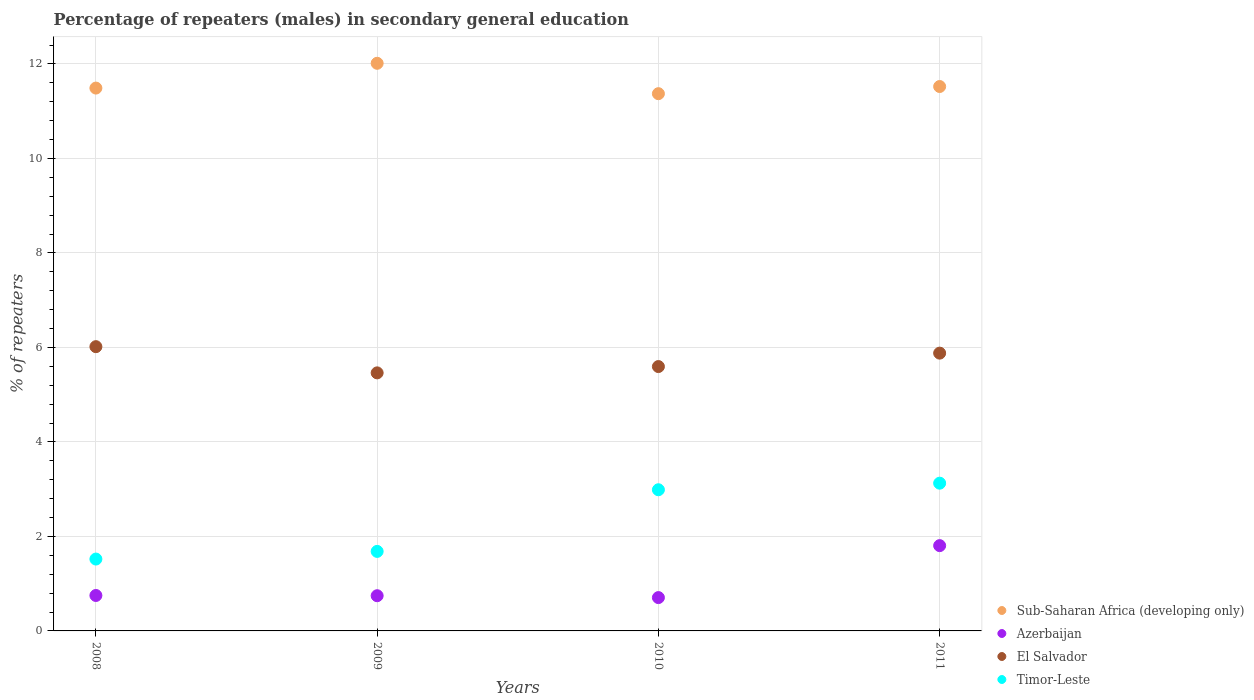Is the number of dotlines equal to the number of legend labels?
Make the answer very short. Yes. What is the percentage of male repeaters in Sub-Saharan Africa (developing only) in 2009?
Give a very brief answer. 12.01. Across all years, what is the maximum percentage of male repeaters in El Salvador?
Ensure brevity in your answer.  6.02. Across all years, what is the minimum percentage of male repeaters in Timor-Leste?
Give a very brief answer. 1.52. In which year was the percentage of male repeaters in El Salvador minimum?
Ensure brevity in your answer.  2009. What is the total percentage of male repeaters in El Salvador in the graph?
Ensure brevity in your answer.  22.95. What is the difference between the percentage of male repeaters in Azerbaijan in 2008 and that in 2010?
Your answer should be very brief. 0.04. What is the difference between the percentage of male repeaters in Sub-Saharan Africa (developing only) in 2011 and the percentage of male repeaters in Timor-Leste in 2009?
Make the answer very short. 9.84. What is the average percentage of male repeaters in Timor-Leste per year?
Offer a very short reply. 2.33. In the year 2008, what is the difference between the percentage of male repeaters in El Salvador and percentage of male repeaters in Timor-Leste?
Provide a succinct answer. 4.5. What is the ratio of the percentage of male repeaters in Timor-Leste in 2008 to that in 2011?
Your answer should be very brief. 0.49. Is the difference between the percentage of male repeaters in El Salvador in 2008 and 2009 greater than the difference between the percentage of male repeaters in Timor-Leste in 2008 and 2009?
Offer a very short reply. Yes. What is the difference between the highest and the second highest percentage of male repeaters in Sub-Saharan Africa (developing only)?
Ensure brevity in your answer.  0.49. What is the difference between the highest and the lowest percentage of male repeaters in Sub-Saharan Africa (developing only)?
Make the answer very short. 0.64. Is it the case that in every year, the sum of the percentage of male repeaters in Azerbaijan and percentage of male repeaters in Timor-Leste  is greater than the sum of percentage of male repeaters in El Salvador and percentage of male repeaters in Sub-Saharan Africa (developing only)?
Your answer should be very brief. No. Is it the case that in every year, the sum of the percentage of male repeaters in Timor-Leste and percentage of male repeaters in Azerbaijan  is greater than the percentage of male repeaters in El Salvador?
Offer a terse response. No. Is the percentage of male repeaters in Azerbaijan strictly greater than the percentage of male repeaters in Sub-Saharan Africa (developing only) over the years?
Offer a very short reply. No. Is the percentage of male repeaters in Azerbaijan strictly less than the percentage of male repeaters in El Salvador over the years?
Keep it short and to the point. Yes. Does the graph contain grids?
Ensure brevity in your answer.  Yes. How are the legend labels stacked?
Offer a terse response. Vertical. What is the title of the graph?
Provide a short and direct response. Percentage of repeaters (males) in secondary general education. Does "Iraq" appear as one of the legend labels in the graph?
Offer a terse response. No. What is the label or title of the X-axis?
Give a very brief answer. Years. What is the label or title of the Y-axis?
Your answer should be very brief. % of repeaters. What is the % of repeaters of Sub-Saharan Africa (developing only) in 2008?
Offer a very short reply. 11.49. What is the % of repeaters in Azerbaijan in 2008?
Offer a very short reply. 0.75. What is the % of repeaters in El Salvador in 2008?
Provide a short and direct response. 6.02. What is the % of repeaters in Timor-Leste in 2008?
Provide a short and direct response. 1.52. What is the % of repeaters in Sub-Saharan Africa (developing only) in 2009?
Ensure brevity in your answer.  12.01. What is the % of repeaters in Azerbaijan in 2009?
Provide a succinct answer. 0.75. What is the % of repeaters in El Salvador in 2009?
Your answer should be compact. 5.46. What is the % of repeaters in Timor-Leste in 2009?
Provide a short and direct response. 1.68. What is the % of repeaters in Sub-Saharan Africa (developing only) in 2010?
Your answer should be very brief. 11.37. What is the % of repeaters in Azerbaijan in 2010?
Keep it short and to the point. 0.71. What is the % of repeaters of El Salvador in 2010?
Make the answer very short. 5.6. What is the % of repeaters in Timor-Leste in 2010?
Offer a very short reply. 2.99. What is the % of repeaters in Sub-Saharan Africa (developing only) in 2011?
Keep it short and to the point. 11.52. What is the % of repeaters in Azerbaijan in 2011?
Provide a succinct answer. 1.81. What is the % of repeaters of El Salvador in 2011?
Give a very brief answer. 5.88. What is the % of repeaters of Timor-Leste in 2011?
Offer a very short reply. 3.13. Across all years, what is the maximum % of repeaters of Sub-Saharan Africa (developing only)?
Provide a succinct answer. 12.01. Across all years, what is the maximum % of repeaters in Azerbaijan?
Your answer should be compact. 1.81. Across all years, what is the maximum % of repeaters in El Salvador?
Your answer should be very brief. 6.02. Across all years, what is the maximum % of repeaters of Timor-Leste?
Provide a succinct answer. 3.13. Across all years, what is the minimum % of repeaters in Sub-Saharan Africa (developing only)?
Make the answer very short. 11.37. Across all years, what is the minimum % of repeaters in Azerbaijan?
Your answer should be very brief. 0.71. Across all years, what is the minimum % of repeaters of El Salvador?
Provide a short and direct response. 5.46. Across all years, what is the minimum % of repeaters in Timor-Leste?
Your response must be concise. 1.52. What is the total % of repeaters in Sub-Saharan Africa (developing only) in the graph?
Offer a very short reply. 46.4. What is the total % of repeaters in Azerbaijan in the graph?
Your response must be concise. 4.01. What is the total % of repeaters of El Salvador in the graph?
Your response must be concise. 22.95. What is the total % of repeaters in Timor-Leste in the graph?
Make the answer very short. 9.32. What is the difference between the % of repeaters in Sub-Saharan Africa (developing only) in 2008 and that in 2009?
Keep it short and to the point. -0.52. What is the difference between the % of repeaters in Azerbaijan in 2008 and that in 2009?
Offer a terse response. 0.01. What is the difference between the % of repeaters of El Salvador in 2008 and that in 2009?
Offer a very short reply. 0.55. What is the difference between the % of repeaters in Timor-Leste in 2008 and that in 2009?
Keep it short and to the point. -0.16. What is the difference between the % of repeaters in Sub-Saharan Africa (developing only) in 2008 and that in 2010?
Offer a terse response. 0.12. What is the difference between the % of repeaters of Azerbaijan in 2008 and that in 2010?
Your answer should be very brief. 0.04. What is the difference between the % of repeaters in El Salvador in 2008 and that in 2010?
Ensure brevity in your answer.  0.42. What is the difference between the % of repeaters of Timor-Leste in 2008 and that in 2010?
Offer a terse response. -1.47. What is the difference between the % of repeaters in Sub-Saharan Africa (developing only) in 2008 and that in 2011?
Offer a terse response. -0.03. What is the difference between the % of repeaters in Azerbaijan in 2008 and that in 2011?
Make the answer very short. -1.06. What is the difference between the % of repeaters of El Salvador in 2008 and that in 2011?
Provide a succinct answer. 0.14. What is the difference between the % of repeaters of Timor-Leste in 2008 and that in 2011?
Keep it short and to the point. -1.61. What is the difference between the % of repeaters in Sub-Saharan Africa (developing only) in 2009 and that in 2010?
Make the answer very short. 0.64. What is the difference between the % of repeaters in Azerbaijan in 2009 and that in 2010?
Provide a short and direct response. 0.04. What is the difference between the % of repeaters in El Salvador in 2009 and that in 2010?
Make the answer very short. -0.13. What is the difference between the % of repeaters of Timor-Leste in 2009 and that in 2010?
Provide a short and direct response. -1.3. What is the difference between the % of repeaters in Sub-Saharan Africa (developing only) in 2009 and that in 2011?
Your answer should be compact. 0.49. What is the difference between the % of repeaters of Azerbaijan in 2009 and that in 2011?
Offer a very short reply. -1.06. What is the difference between the % of repeaters in El Salvador in 2009 and that in 2011?
Your response must be concise. -0.42. What is the difference between the % of repeaters of Timor-Leste in 2009 and that in 2011?
Offer a terse response. -1.44. What is the difference between the % of repeaters of Sub-Saharan Africa (developing only) in 2010 and that in 2011?
Offer a terse response. -0.15. What is the difference between the % of repeaters of Azerbaijan in 2010 and that in 2011?
Make the answer very short. -1.1. What is the difference between the % of repeaters of El Salvador in 2010 and that in 2011?
Keep it short and to the point. -0.28. What is the difference between the % of repeaters in Timor-Leste in 2010 and that in 2011?
Ensure brevity in your answer.  -0.14. What is the difference between the % of repeaters in Sub-Saharan Africa (developing only) in 2008 and the % of repeaters in Azerbaijan in 2009?
Your answer should be very brief. 10.74. What is the difference between the % of repeaters of Sub-Saharan Africa (developing only) in 2008 and the % of repeaters of El Salvador in 2009?
Ensure brevity in your answer.  6.03. What is the difference between the % of repeaters in Sub-Saharan Africa (developing only) in 2008 and the % of repeaters in Timor-Leste in 2009?
Provide a succinct answer. 9.81. What is the difference between the % of repeaters in Azerbaijan in 2008 and the % of repeaters in El Salvador in 2009?
Make the answer very short. -4.71. What is the difference between the % of repeaters of Azerbaijan in 2008 and the % of repeaters of Timor-Leste in 2009?
Give a very brief answer. -0.93. What is the difference between the % of repeaters of El Salvador in 2008 and the % of repeaters of Timor-Leste in 2009?
Offer a terse response. 4.33. What is the difference between the % of repeaters in Sub-Saharan Africa (developing only) in 2008 and the % of repeaters in Azerbaijan in 2010?
Your answer should be compact. 10.78. What is the difference between the % of repeaters in Sub-Saharan Africa (developing only) in 2008 and the % of repeaters in El Salvador in 2010?
Provide a short and direct response. 5.89. What is the difference between the % of repeaters of Sub-Saharan Africa (developing only) in 2008 and the % of repeaters of Timor-Leste in 2010?
Keep it short and to the point. 8.5. What is the difference between the % of repeaters of Azerbaijan in 2008 and the % of repeaters of El Salvador in 2010?
Your answer should be compact. -4.85. What is the difference between the % of repeaters in Azerbaijan in 2008 and the % of repeaters in Timor-Leste in 2010?
Your response must be concise. -2.24. What is the difference between the % of repeaters of El Salvador in 2008 and the % of repeaters of Timor-Leste in 2010?
Your answer should be very brief. 3.03. What is the difference between the % of repeaters of Sub-Saharan Africa (developing only) in 2008 and the % of repeaters of Azerbaijan in 2011?
Ensure brevity in your answer.  9.68. What is the difference between the % of repeaters of Sub-Saharan Africa (developing only) in 2008 and the % of repeaters of El Salvador in 2011?
Provide a short and direct response. 5.61. What is the difference between the % of repeaters in Sub-Saharan Africa (developing only) in 2008 and the % of repeaters in Timor-Leste in 2011?
Keep it short and to the point. 8.36. What is the difference between the % of repeaters in Azerbaijan in 2008 and the % of repeaters in El Salvador in 2011?
Your answer should be very brief. -5.13. What is the difference between the % of repeaters of Azerbaijan in 2008 and the % of repeaters of Timor-Leste in 2011?
Provide a short and direct response. -2.38. What is the difference between the % of repeaters in El Salvador in 2008 and the % of repeaters in Timor-Leste in 2011?
Offer a very short reply. 2.89. What is the difference between the % of repeaters of Sub-Saharan Africa (developing only) in 2009 and the % of repeaters of Azerbaijan in 2010?
Ensure brevity in your answer.  11.31. What is the difference between the % of repeaters in Sub-Saharan Africa (developing only) in 2009 and the % of repeaters in El Salvador in 2010?
Provide a short and direct response. 6.42. What is the difference between the % of repeaters of Sub-Saharan Africa (developing only) in 2009 and the % of repeaters of Timor-Leste in 2010?
Give a very brief answer. 9.03. What is the difference between the % of repeaters in Azerbaijan in 2009 and the % of repeaters in El Salvador in 2010?
Your answer should be very brief. -4.85. What is the difference between the % of repeaters in Azerbaijan in 2009 and the % of repeaters in Timor-Leste in 2010?
Provide a short and direct response. -2.24. What is the difference between the % of repeaters in El Salvador in 2009 and the % of repeaters in Timor-Leste in 2010?
Your answer should be very brief. 2.47. What is the difference between the % of repeaters in Sub-Saharan Africa (developing only) in 2009 and the % of repeaters in Azerbaijan in 2011?
Make the answer very short. 10.21. What is the difference between the % of repeaters of Sub-Saharan Africa (developing only) in 2009 and the % of repeaters of El Salvador in 2011?
Provide a short and direct response. 6.13. What is the difference between the % of repeaters in Sub-Saharan Africa (developing only) in 2009 and the % of repeaters in Timor-Leste in 2011?
Offer a terse response. 8.89. What is the difference between the % of repeaters of Azerbaijan in 2009 and the % of repeaters of El Salvador in 2011?
Keep it short and to the point. -5.13. What is the difference between the % of repeaters of Azerbaijan in 2009 and the % of repeaters of Timor-Leste in 2011?
Your response must be concise. -2.38. What is the difference between the % of repeaters of El Salvador in 2009 and the % of repeaters of Timor-Leste in 2011?
Provide a succinct answer. 2.33. What is the difference between the % of repeaters in Sub-Saharan Africa (developing only) in 2010 and the % of repeaters in Azerbaijan in 2011?
Provide a short and direct response. 9.57. What is the difference between the % of repeaters in Sub-Saharan Africa (developing only) in 2010 and the % of repeaters in El Salvador in 2011?
Provide a short and direct response. 5.49. What is the difference between the % of repeaters in Sub-Saharan Africa (developing only) in 2010 and the % of repeaters in Timor-Leste in 2011?
Your answer should be very brief. 8.24. What is the difference between the % of repeaters of Azerbaijan in 2010 and the % of repeaters of El Salvador in 2011?
Your answer should be very brief. -5.17. What is the difference between the % of repeaters in Azerbaijan in 2010 and the % of repeaters in Timor-Leste in 2011?
Make the answer very short. -2.42. What is the difference between the % of repeaters of El Salvador in 2010 and the % of repeaters of Timor-Leste in 2011?
Ensure brevity in your answer.  2.47. What is the average % of repeaters of Sub-Saharan Africa (developing only) per year?
Your answer should be compact. 11.6. What is the average % of repeaters in Azerbaijan per year?
Your answer should be compact. 1. What is the average % of repeaters in El Salvador per year?
Offer a terse response. 5.74. What is the average % of repeaters in Timor-Leste per year?
Keep it short and to the point. 2.33. In the year 2008, what is the difference between the % of repeaters in Sub-Saharan Africa (developing only) and % of repeaters in Azerbaijan?
Offer a terse response. 10.74. In the year 2008, what is the difference between the % of repeaters of Sub-Saharan Africa (developing only) and % of repeaters of El Salvador?
Keep it short and to the point. 5.47. In the year 2008, what is the difference between the % of repeaters in Sub-Saharan Africa (developing only) and % of repeaters in Timor-Leste?
Give a very brief answer. 9.97. In the year 2008, what is the difference between the % of repeaters of Azerbaijan and % of repeaters of El Salvador?
Provide a short and direct response. -5.27. In the year 2008, what is the difference between the % of repeaters of Azerbaijan and % of repeaters of Timor-Leste?
Offer a very short reply. -0.77. In the year 2008, what is the difference between the % of repeaters in El Salvador and % of repeaters in Timor-Leste?
Offer a terse response. 4.5. In the year 2009, what is the difference between the % of repeaters of Sub-Saharan Africa (developing only) and % of repeaters of Azerbaijan?
Give a very brief answer. 11.27. In the year 2009, what is the difference between the % of repeaters of Sub-Saharan Africa (developing only) and % of repeaters of El Salvador?
Keep it short and to the point. 6.55. In the year 2009, what is the difference between the % of repeaters in Sub-Saharan Africa (developing only) and % of repeaters in Timor-Leste?
Keep it short and to the point. 10.33. In the year 2009, what is the difference between the % of repeaters in Azerbaijan and % of repeaters in El Salvador?
Ensure brevity in your answer.  -4.72. In the year 2009, what is the difference between the % of repeaters of Azerbaijan and % of repeaters of Timor-Leste?
Provide a short and direct response. -0.94. In the year 2009, what is the difference between the % of repeaters in El Salvador and % of repeaters in Timor-Leste?
Provide a succinct answer. 3.78. In the year 2010, what is the difference between the % of repeaters in Sub-Saharan Africa (developing only) and % of repeaters in Azerbaijan?
Offer a terse response. 10.67. In the year 2010, what is the difference between the % of repeaters in Sub-Saharan Africa (developing only) and % of repeaters in El Salvador?
Make the answer very short. 5.78. In the year 2010, what is the difference between the % of repeaters of Sub-Saharan Africa (developing only) and % of repeaters of Timor-Leste?
Offer a very short reply. 8.38. In the year 2010, what is the difference between the % of repeaters of Azerbaijan and % of repeaters of El Salvador?
Keep it short and to the point. -4.89. In the year 2010, what is the difference between the % of repeaters of Azerbaijan and % of repeaters of Timor-Leste?
Your response must be concise. -2.28. In the year 2010, what is the difference between the % of repeaters in El Salvador and % of repeaters in Timor-Leste?
Give a very brief answer. 2.61. In the year 2011, what is the difference between the % of repeaters in Sub-Saharan Africa (developing only) and % of repeaters in Azerbaijan?
Your response must be concise. 9.72. In the year 2011, what is the difference between the % of repeaters in Sub-Saharan Africa (developing only) and % of repeaters in El Salvador?
Make the answer very short. 5.64. In the year 2011, what is the difference between the % of repeaters in Sub-Saharan Africa (developing only) and % of repeaters in Timor-Leste?
Ensure brevity in your answer.  8.4. In the year 2011, what is the difference between the % of repeaters of Azerbaijan and % of repeaters of El Salvador?
Your answer should be compact. -4.07. In the year 2011, what is the difference between the % of repeaters of Azerbaijan and % of repeaters of Timor-Leste?
Provide a short and direct response. -1.32. In the year 2011, what is the difference between the % of repeaters in El Salvador and % of repeaters in Timor-Leste?
Offer a terse response. 2.75. What is the ratio of the % of repeaters in Sub-Saharan Africa (developing only) in 2008 to that in 2009?
Keep it short and to the point. 0.96. What is the ratio of the % of repeaters of Azerbaijan in 2008 to that in 2009?
Make the answer very short. 1.01. What is the ratio of the % of repeaters of El Salvador in 2008 to that in 2009?
Offer a very short reply. 1.1. What is the ratio of the % of repeaters of Timor-Leste in 2008 to that in 2009?
Offer a very short reply. 0.9. What is the ratio of the % of repeaters of Sub-Saharan Africa (developing only) in 2008 to that in 2010?
Your response must be concise. 1.01. What is the ratio of the % of repeaters in Azerbaijan in 2008 to that in 2010?
Your answer should be compact. 1.06. What is the ratio of the % of repeaters in El Salvador in 2008 to that in 2010?
Make the answer very short. 1.08. What is the ratio of the % of repeaters in Timor-Leste in 2008 to that in 2010?
Keep it short and to the point. 0.51. What is the ratio of the % of repeaters of Azerbaijan in 2008 to that in 2011?
Offer a very short reply. 0.42. What is the ratio of the % of repeaters in El Salvador in 2008 to that in 2011?
Offer a terse response. 1.02. What is the ratio of the % of repeaters in Timor-Leste in 2008 to that in 2011?
Offer a terse response. 0.49. What is the ratio of the % of repeaters in Sub-Saharan Africa (developing only) in 2009 to that in 2010?
Your answer should be compact. 1.06. What is the ratio of the % of repeaters in Azerbaijan in 2009 to that in 2010?
Provide a succinct answer. 1.06. What is the ratio of the % of repeaters of El Salvador in 2009 to that in 2010?
Provide a short and direct response. 0.98. What is the ratio of the % of repeaters of Timor-Leste in 2009 to that in 2010?
Offer a very short reply. 0.56. What is the ratio of the % of repeaters of Sub-Saharan Africa (developing only) in 2009 to that in 2011?
Provide a succinct answer. 1.04. What is the ratio of the % of repeaters in Azerbaijan in 2009 to that in 2011?
Your answer should be very brief. 0.41. What is the ratio of the % of repeaters in El Salvador in 2009 to that in 2011?
Provide a short and direct response. 0.93. What is the ratio of the % of repeaters of Timor-Leste in 2009 to that in 2011?
Your answer should be compact. 0.54. What is the ratio of the % of repeaters of Sub-Saharan Africa (developing only) in 2010 to that in 2011?
Provide a succinct answer. 0.99. What is the ratio of the % of repeaters in Azerbaijan in 2010 to that in 2011?
Your response must be concise. 0.39. What is the ratio of the % of repeaters in El Salvador in 2010 to that in 2011?
Your answer should be very brief. 0.95. What is the ratio of the % of repeaters of Timor-Leste in 2010 to that in 2011?
Offer a terse response. 0.96. What is the difference between the highest and the second highest % of repeaters in Sub-Saharan Africa (developing only)?
Keep it short and to the point. 0.49. What is the difference between the highest and the second highest % of repeaters of Azerbaijan?
Give a very brief answer. 1.06. What is the difference between the highest and the second highest % of repeaters of El Salvador?
Ensure brevity in your answer.  0.14. What is the difference between the highest and the second highest % of repeaters in Timor-Leste?
Provide a short and direct response. 0.14. What is the difference between the highest and the lowest % of repeaters of Sub-Saharan Africa (developing only)?
Give a very brief answer. 0.64. What is the difference between the highest and the lowest % of repeaters in Azerbaijan?
Your answer should be compact. 1.1. What is the difference between the highest and the lowest % of repeaters of El Salvador?
Your response must be concise. 0.55. What is the difference between the highest and the lowest % of repeaters in Timor-Leste?
Your answer should be very brief. 1.61. 